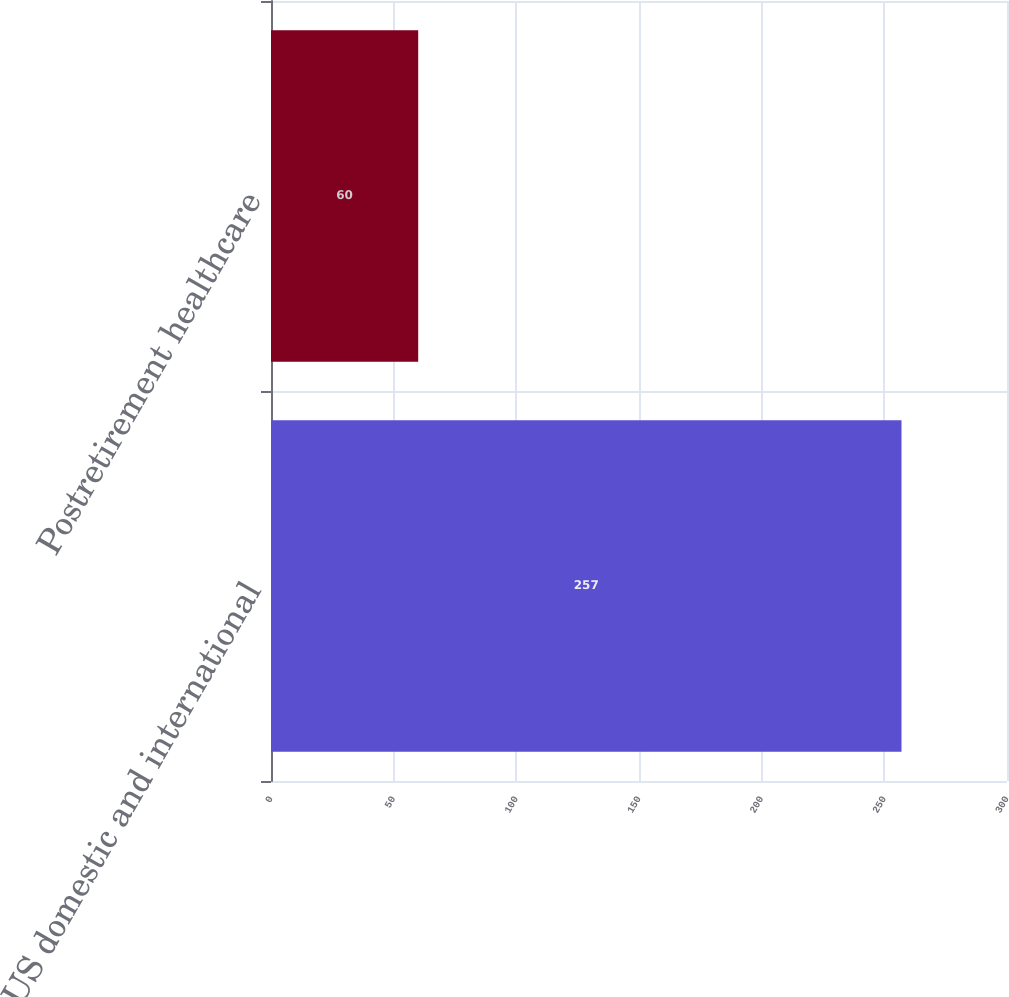<chart> <loc_0><loc_0><loc_500><loc_500><bar_chart><fcel>US domestic and international<fcel>Postretirement healthcare<nl><fcel>257<fcel>60<nl></chart> 